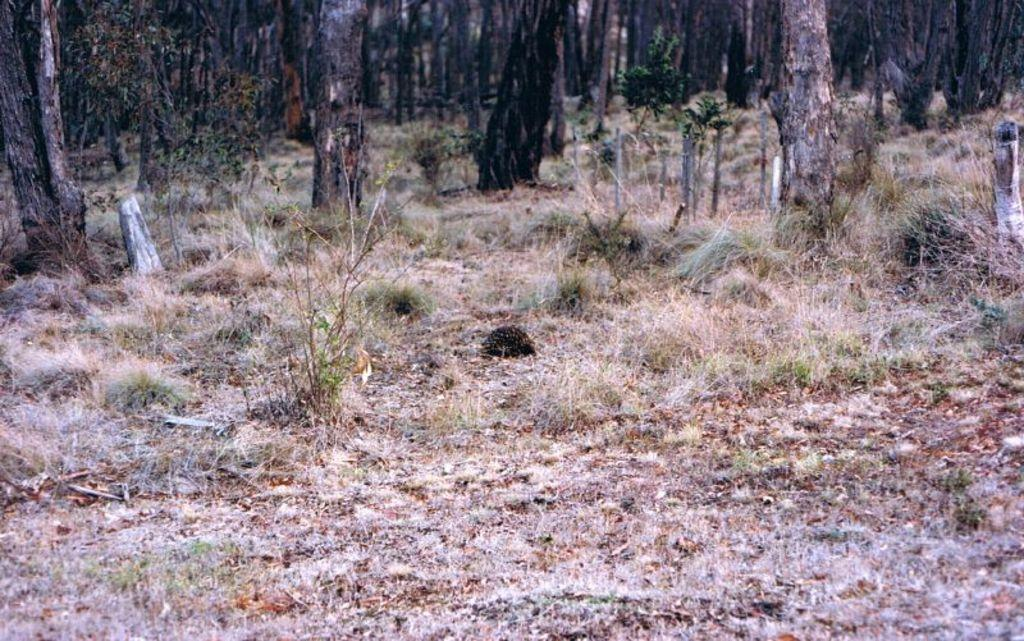What type of vegetation is present in the image? There is dry grass in the image. What other natural elements can be seen in the image? There are trees in the image. Where is the volleyball court located in the image? There is no volleyball court present in the image. What type of basin can be seen in the image? There is no basin present in the image. 